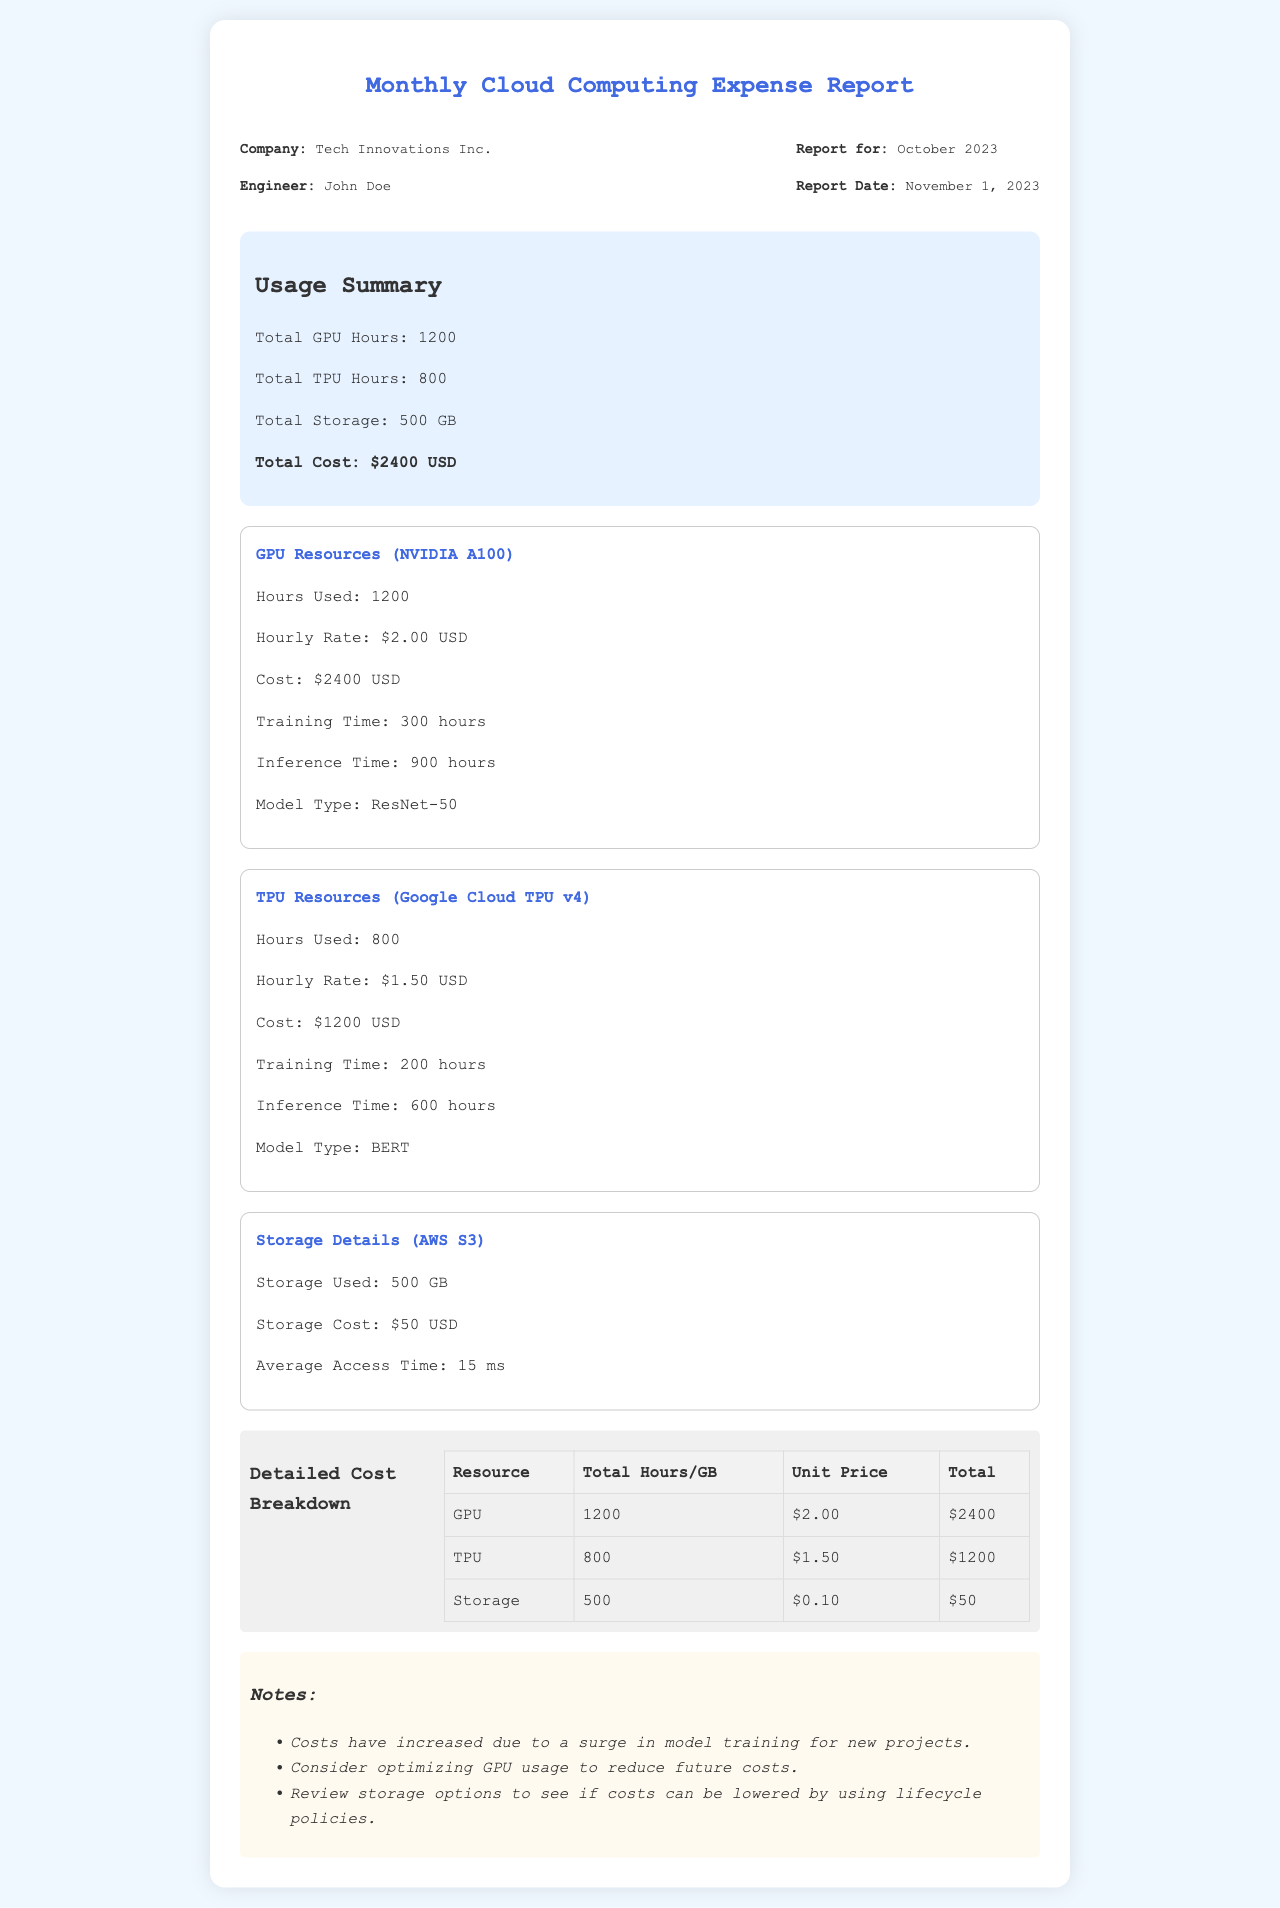what is the report date? The report date is mentioned in the header section of the document, which states "Report Date: November 1, 2023."
Answer: November 1, 2023 how many total GPU hours were used? The usage summary indicates the total GPU hours used, which is "Total GPU Hours: 1200."
Answer: 1200 what is the cost of TPU resources? The TPU resource section specifies the cost as "Cost: $1200 USD."
Answer: $1200 USD what is the average access time for storage? The storage details section provides the average access time as "Average Access Time: 15 ms."
Answer: 15 ms how much was spent on storage? The storage details section states the cost as "Storage Cost: $50 USD."
Answer: $50 USD how many hours were used for training on GPUs? The GPU resource section specifies "Training Time: 300 hours."
Answer: 300 hours what is the total cost for all resources? The usage summary provides the total cost as "Total Cost: $2400 USD."
Answer: $2400 USD which model type was used for TPU resources? The TPU resource section mentions "Model Type: BERT."
Answer: BERT how many hours were used for inference on TPUs? The TPU resource section specifies "Inference Time: 600 hours."
Answer: 600 hours 